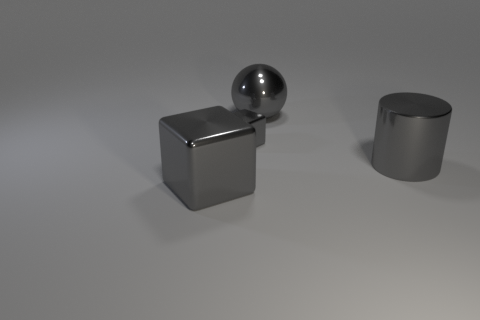There is a metal cube that is behind the big gray cylinder; is its color the same as the shiny cube in front of the cylinder?
Give a very brief answer. Yes. There is another gray object that is the same shape as the small metal thing; what is it made of?
Offer a terse response. Metal. Are there fewer big gray objects than objects?
Make the answer very short. Yes. How many other things are the same color as the big sphere?
Provide a succinct answer. 3. Are there more small gray shiny blocks than cyan shiny things?
Provide a succinct answer. Yes. Does the cylinder have the same size as the cube behind the gray metal cylinder?
Provide a succinct answer. No. What color is the block to the left of the small gray thing?
Give a very brief answer. Gray. How many gray objects are either cylinders or shiny things?
Your answer should be very brief. 4. The metallic cylinder is what color?
Your answer should be compact. Gray. Is the number of gray metallic balls to the right of the cylinder less than the number of things left of the big gray ball?
Provide a succinct answer. Yes. 